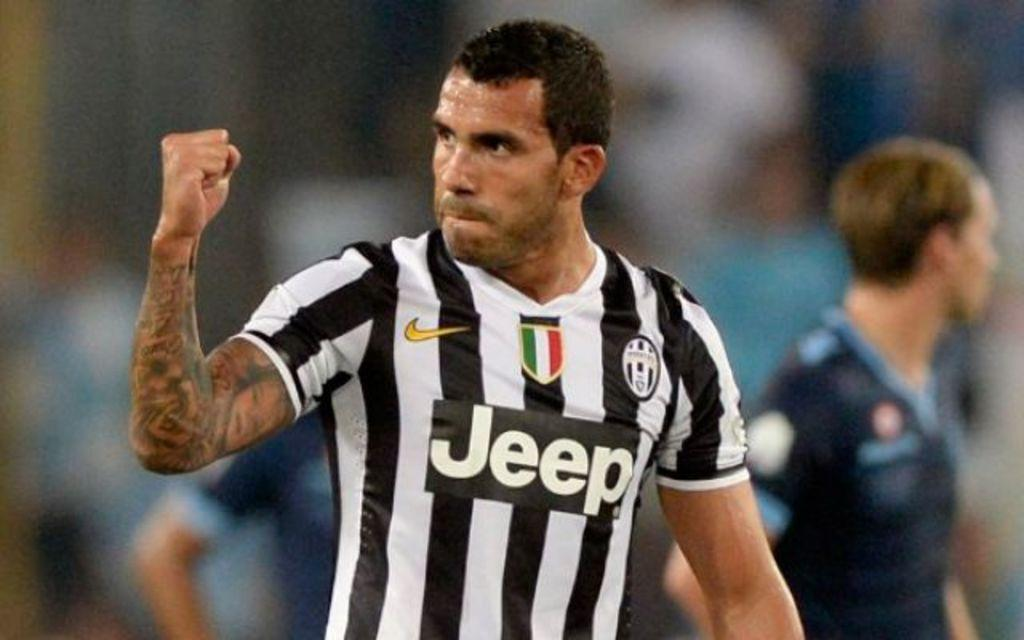<image>
Render a clear and concise summary of the photo. A referee wearing a Jeep shirt with his fist in the air. 